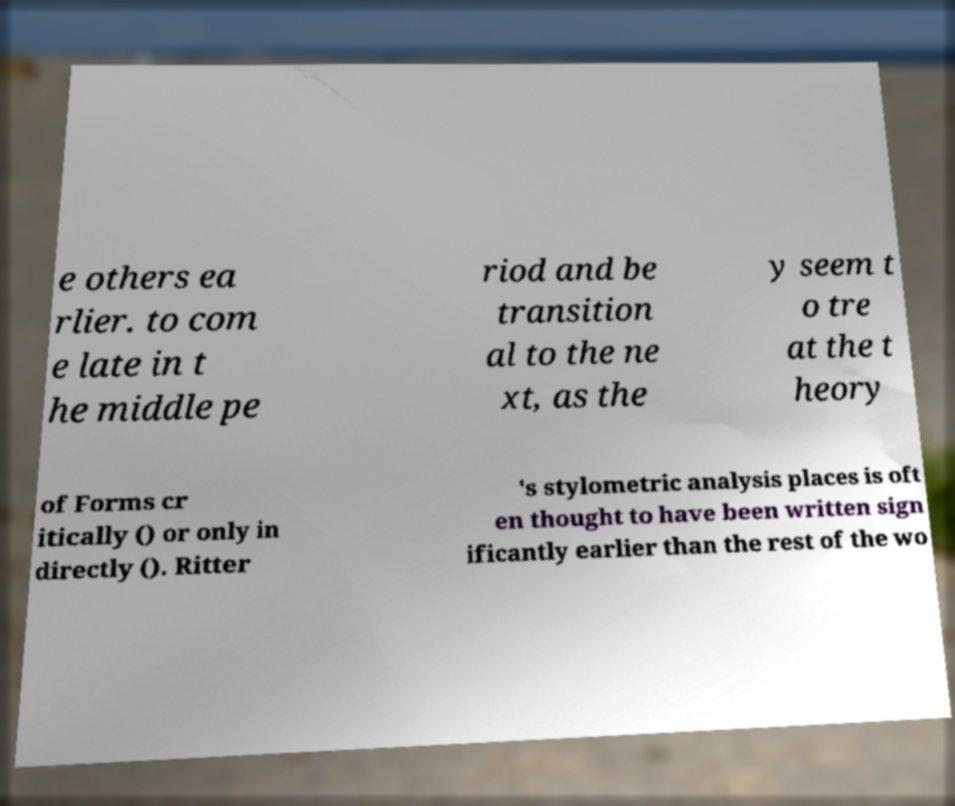Could you extract and type out the text from this image? e others ea rlier. to com e late in t he middle pe riod and be transition al to the ne xt, as the y seem t o tre at the t heory of Forms cr itically () or only in directly (). Ritter 's stylometric analysis places is oft en thought to have been written sign ificantly earlier than the rest of the wo 